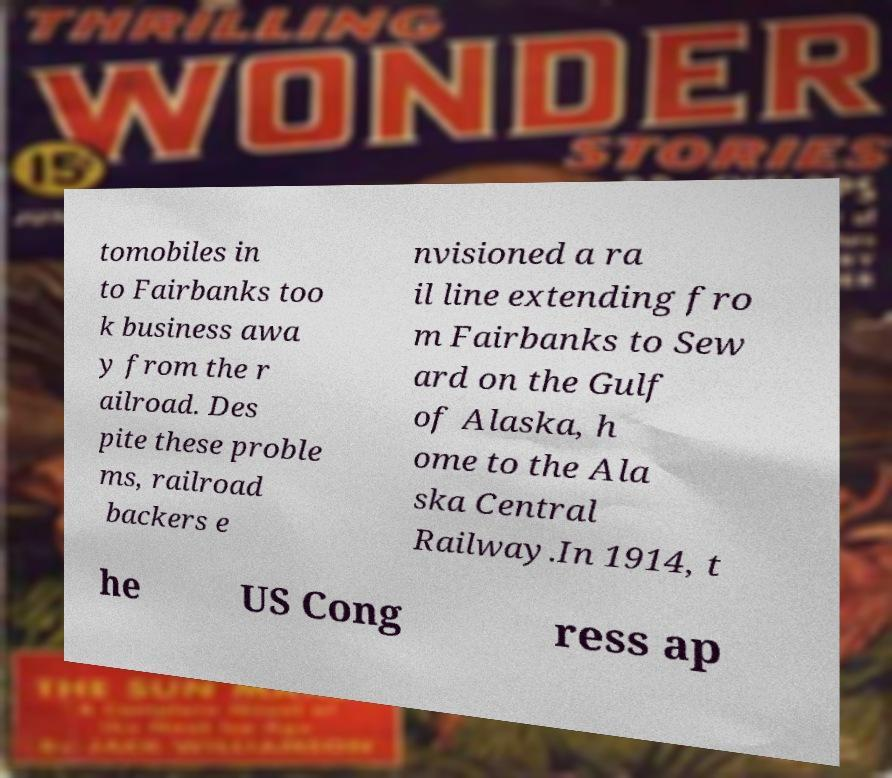What messages or text are displayed in this image? I need them in a readable, typed format. tomobiles in to Fairbanks too k business awa y from the r ailroad. Des pite these proble ms, railroad backers e nvisioned a ra il line extending fro m Fairbanks to Sew ard on the Gulf of Alaska, h ome to the Ala ska Central Railway.In 1914, t he US Cong ress ap 